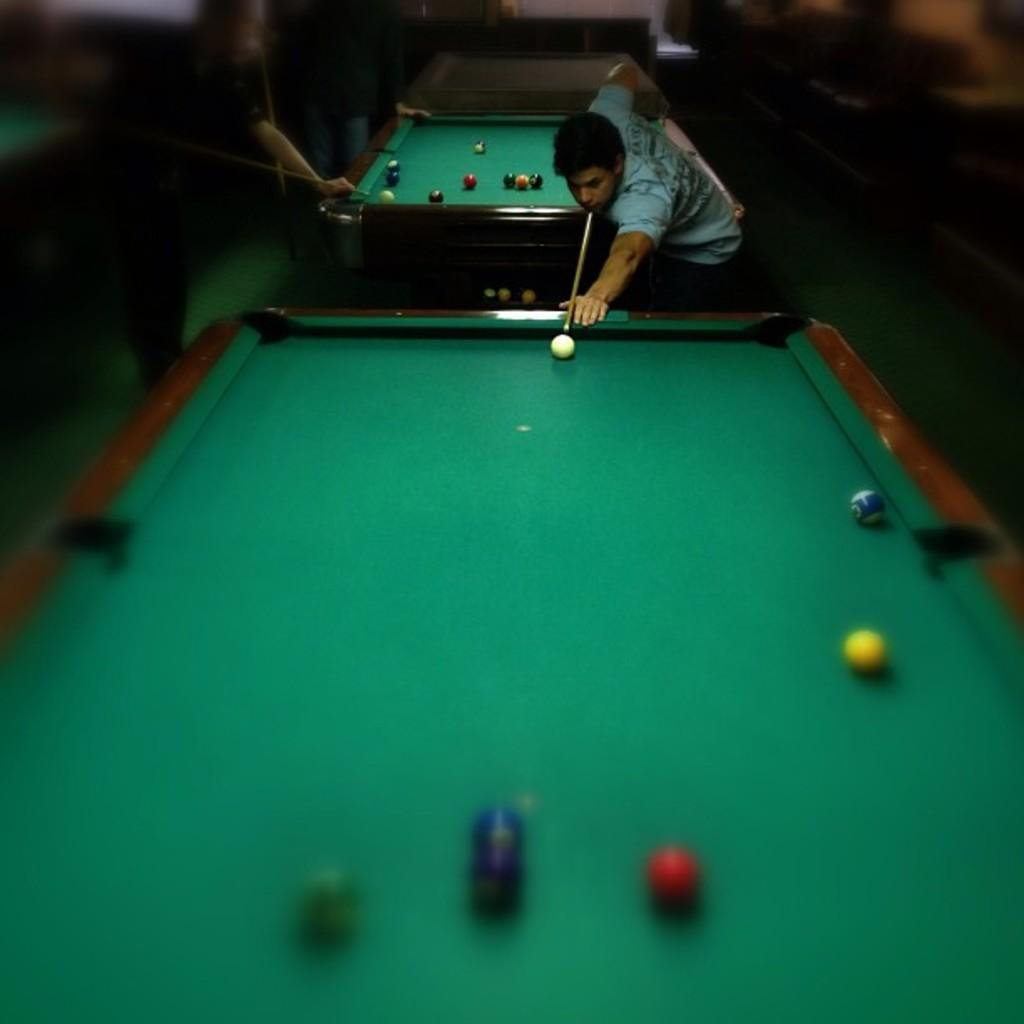Who or what can be seen in the image? There are people in the image. What activity might the people be engaged in? The presence of pool tables in the image suggests that the people might be playing pool or engaging in a related activity. Can you see the ocean in the image? No, the ocean is not present in the image; it features people and pool tables. What type of beast can be seen interacting with the pool tables in the image? There are no beasts present in the image; it features people and pool tables. 